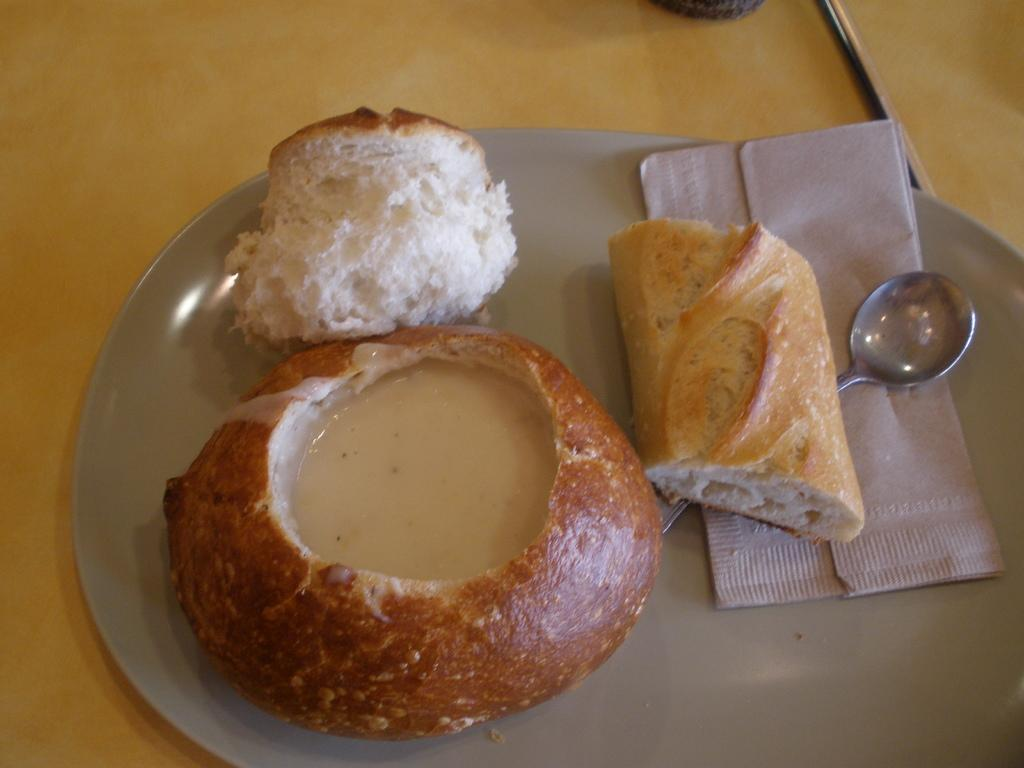What is the main subject in the center of the image? There is food in the center of the image. What item can be seen for cleaning or wiping in the image? There is a tissue in the image. What utensil is present in the image? There is a spoon in the image. Where is the spoon placed in the image? The spoon is placed on a plate. On what surface is the plate placed in the image? The plate is placed on a table. What type of territory is visible in the image? There is no territory visible in the image; it features food, a tissue, a spoon, a plate, and a table. 